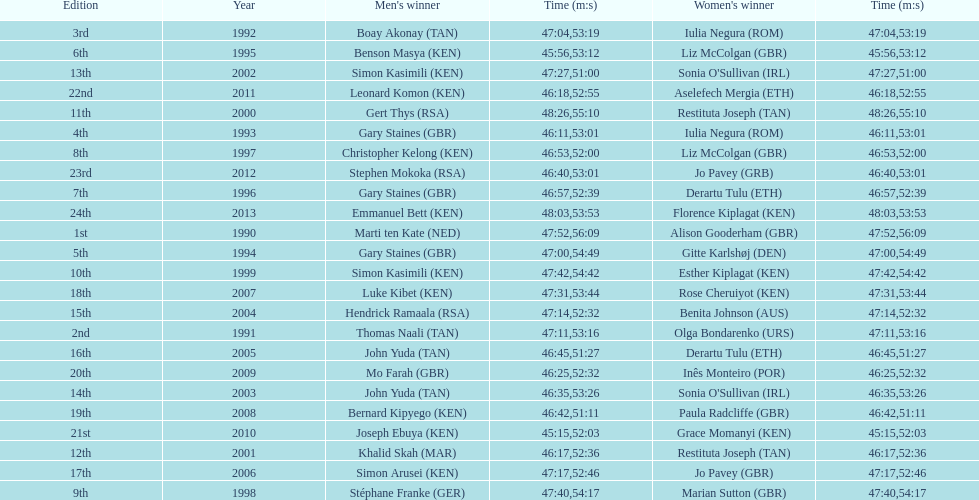How long did sonia o'sullivan take to finish in 2003? 53:26. 